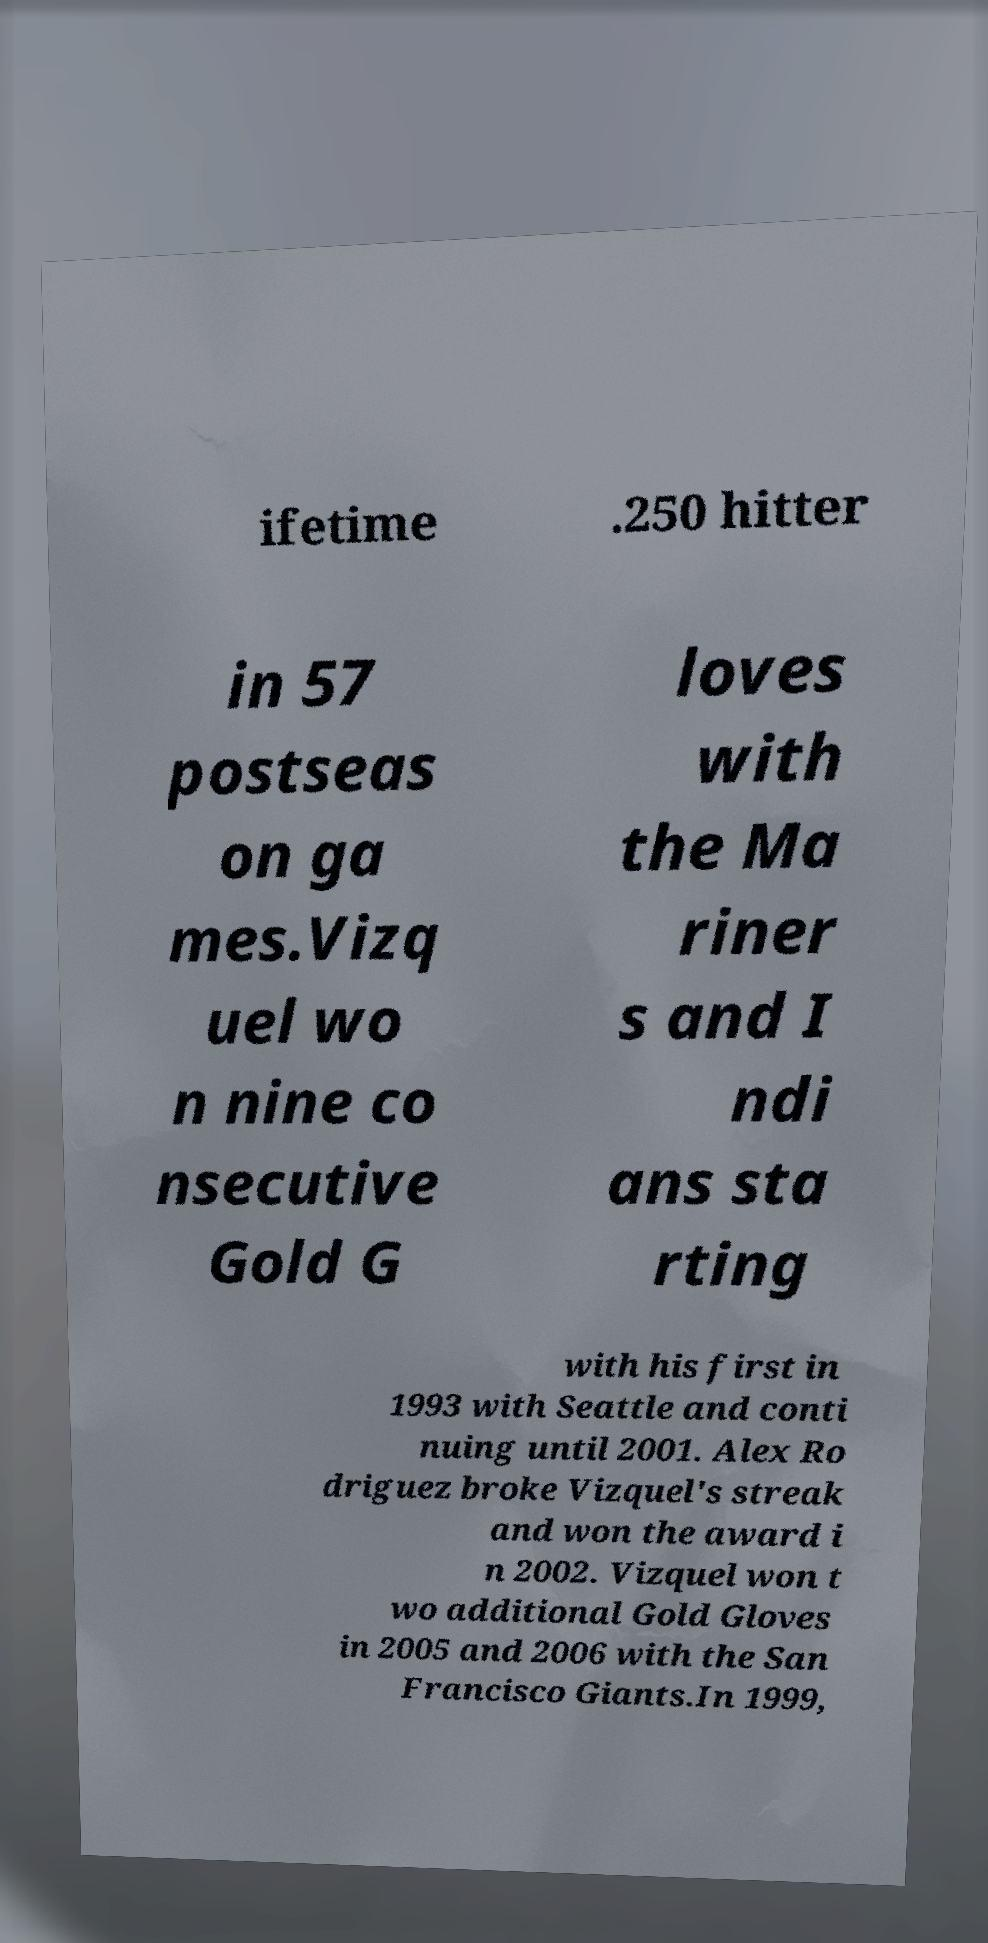Could you extract and type out the text from this image? ifetime .250 hitter in 57 postseas on ga mes.Vizq uel wo n nine co nsecutive Gold G loves with the Ma riner s and I ndi ans sta rting with his first in 1993 with Seattle and conti nuing until 2001. Alex Ro driguez broke Vizquel's streak and won the award i n 2002. Vizquel won t wo additional Gold Gloves in 2005 and 2006 with the San Francisco Giants.In 1999, 